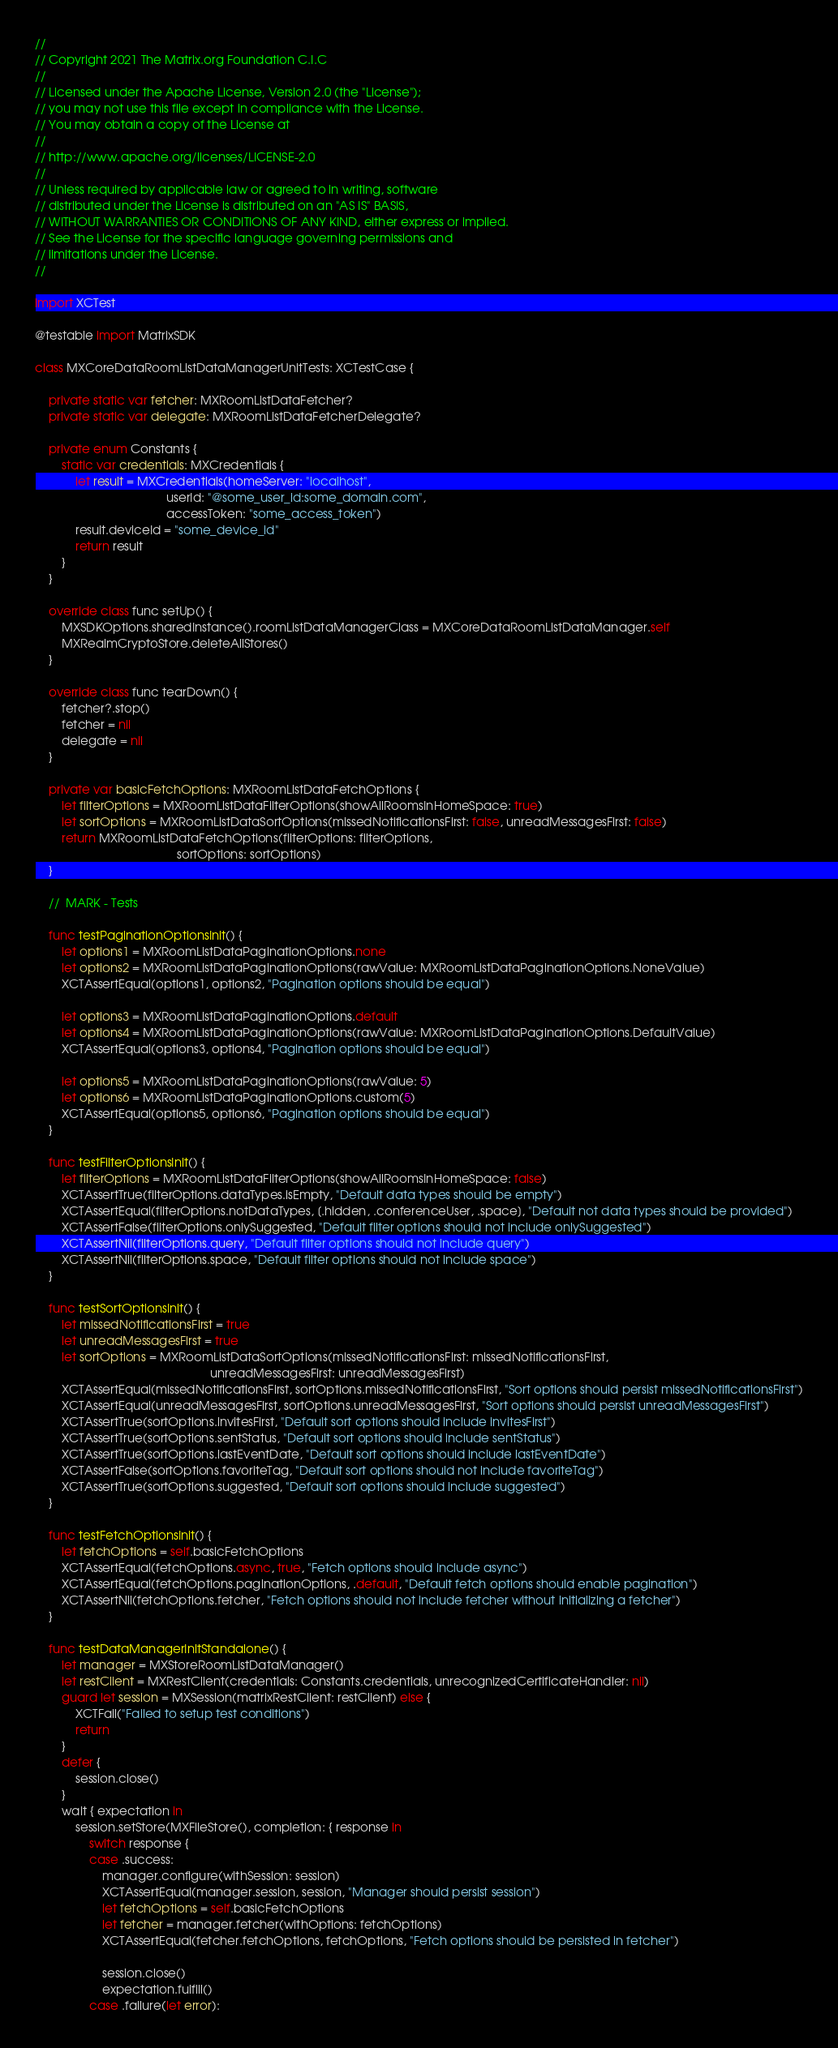Convert code to text. <code><loc_0><loc_0><loc_500><loc_500><_Swift_>// 
// Copyright 2021 The Matrix.org Foundation C.I.C
//
// Licensed under the Apache License, Version 2.0 (the "License");
// you may not use this file except in compliance with the License.
// You may obtain a copy of the License at
//
// http://www.apache.org/licenses/LICENSE-2.0
//
// Unless required by applicable law or agreed to in writing, software
// distributed under the License is distributed on an "AS IS" BASIS,
// WITHOUT WARRANTIES OR CONDITIONS OF ANY KIND, either express or implied.
// See the License for the specific language governing permissions and
// limitations under the License.
//

import XCTest

@testable import MatrixSDK

class MXCoreDataRoomListDataManagerUnitTests: XCTestCase {
    
    private static var fetcher: MXRoomListDataFetcher?
    private static var delegate: MXRoomListDataFetcherDelegate?
    
    private enum Constants {
        static var credentials: MXCredentials {
            let result = MXCredentials(homeServer: "localhost",
                                       userId: "@some_user_id:some_domain.com",
                                       accessToken: "some_access_token")
            result.deviceId = "some_device_id"
            return result
        }
    }
    
    override class func setUp() {
        MXSDKOptions.sharedInstance().roomListDataManagerClass = MXCoreDataRoomListDataManager.self
        MXRealmCryptoStore.deleteAllStores()
    }
    
    override class func tearDown() {
        fetcher?.stop()
        fetcher = nil
        delegate = nil
    }
    
    private var basicFetchOptions: MXRoomListDataFetchOptions {
        let filterOptions = MXRoomListDataFilterOptions(showAllRoomsInHomeSpace: true)
        let sortOptions = MXRoomListDataSortOptions(missedNotificationsFirst: false, unreadMessagesFirst: false)
        return MXRoomListDataFetchOptions(filterOptions: filterOptions,
                                          sortOptions: sortOptions)
    }
    
    //  MARK - Tests
    
    func testPaginationOptionsInit() {
        let options1 = MXRoomListDataPaginationOptions.none
        let options2 = MXRoomListDataPaginationOptions(rawValue: MXRoomListDataPaginationOptions.NoneValue)
        XCTAssertEqual(options1, options2, "Pagination options should be equal")
        
        let options3 = MXRoomListDataPaginationOptions.default
        let options4 = MXRoomListDataPaginationOptions(rawValue: MXRoomListDataPaginationOptions.DefaultValue)
        XCTAssertEqual(options3, options4, "Pagination options should be equal")
        
        let options5 = MXRoomListDataPaginationOptions(rawValue: 5)
        let options6 = MXRoomListDataPaginationOptions.custom(5)
        XCTAssertEqual(options5, options6, "Pagination options should be equal")
    }
    
    func testFilterOptionsInit() {
        let filterOptions = MXRoomListDataFilterOptions(showAllRoomsInHomeSpace: false)
        XCTAssertTrue(filterOptions.dataTypes.isEmpty, "Default data types should be empty")
        XCTAssertEqual(filterOptions.notDataTypes, [.hidden, .conferenceUser, .space], "Default not data types should be provided")
        XCTAssertFalse(filterOptions.onlySuggested, "Default filter options should not include onlySuggested")
        XCTAssertNil(filterOptions.query, "Default filter options should not include query")
        XCTAssertNil(filterOptions.space, "Default filter options should not include space")
    }
    
    func testSortOptionsInit() {
        let missedNotificationsFirst = true
        let unreadMessagesFirst = true
        let sortOptions = MXRoomListDataSortOptions(missedNotificationsFirst: missedNotificationsFirst,
                                                    unreadMessagesFirst: unreadMessagesFirst)
        XCTAssertEqual(missedNotificationsFirst, sortOptions.missedNotificationsFirst, "Sort options should persist missedNotificationsFirst")
        XCTAssertEqual(unreadMessagesFirst, sortOptions.unreadMessagesFirst, "Sort options should persist unreadMessagesFirst")
        XCTAssertTrue(sortOptions.invitesFirst, "Default sort options should include invitesFirst")
        XCTAssertTrue(sortOptions.sentStatus, "Default sort options should include sentStatus")
        XCTAssertTrue(sortOptions.lastEventDate, "Default sort options should include lastEventDate")
        XCTAssertFalse(sortOptions.favoriteTag, "Default sort options should not include favoriteTag")
        XCTAssertTrue(sortOptions.suggested, "Default sort options should include suggested")
    }
    
    func testFetchOptionsInit() {
        let fetchOptions = self.basicFetchOptions
        XCTAssertEqual(fetchOptions.async, true, "Fetch options should include async")
        XCTAssertEqual(fetchOptions.paginationOptions, .default, "Default fetch options should enable pagination")
        XCTAssertNil(fetchOptions.fetcher, "Fetch options should not include fetcher without initializing a fetcher")
    }
    
    func testDataManagerInitStandalone() {
        let manager = MXStoreRoomListDataManager()
        let restClient = MXRestClient(credentials: Constants.credentials, unrecognizedCertificateHandler: nil)
        guard let session = MXSession(matrixRestClient: restClient) else {
            XCTFail("Failed to setup test conditions")
            return
        }
        defer {
            session.close()
        }
        wait { expectation in
            session.setStore(MXFileStore(), completion: { response in
                switch response {
                case .success:
                    manager.configure(withSession: session)
                    XCTAssertEqual(manager.session, session, "Manager should persist session")
                    let fetchOptions = self.basicFetchOptions
                    let fetcher = manager.fetcher(withOptions: fetchOptions)
                    XCTAssertEqual(fetcher.fetchOptions, fetchOptions, "Fetch options should be persisted in fetcher")
                    
                    session.close()
                    expectation.fulfill()
                case .failure(let error):</code> 